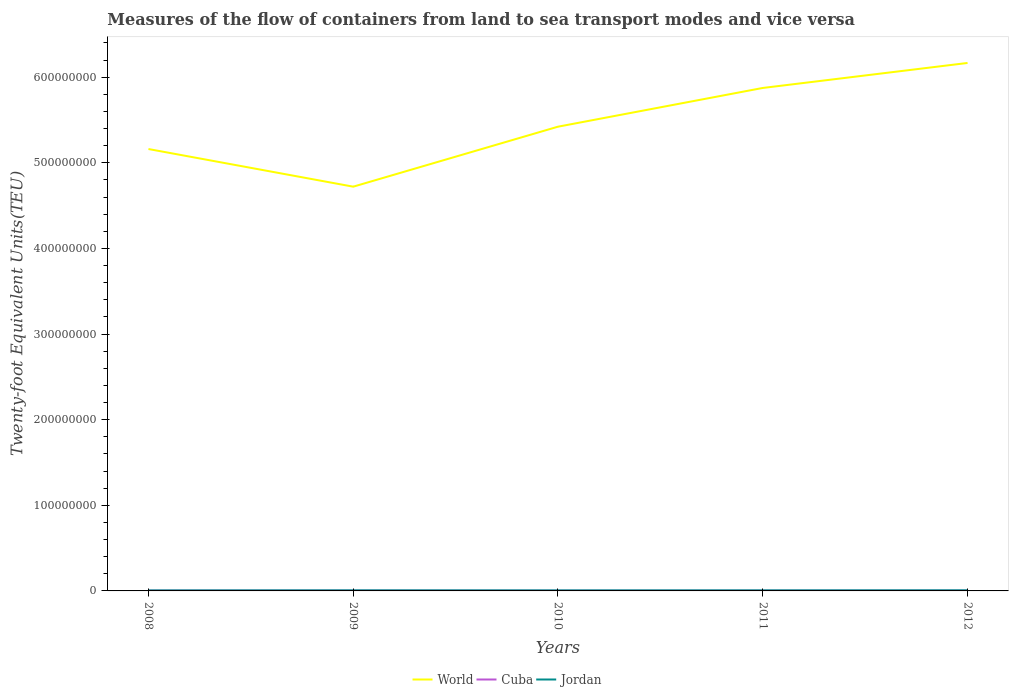Does the line corresponding to World intersect with the line corresponding to Cuba?
Offer a very short reply. No. Across all years, what is the maximum container port traffic in World?
Your answer should be very brief. 4.72e+08. What is the total container port traffic in Cuba in the graph?
Make the answer very short. 9.07e+04. What is the difference between the highest and the second highest container port traffic in World?
Offer a terse response. 1.44e+08. What is the difference between two consecutive major ticks on the Y-axis?
Make the answer very short. 1.00e+08. Are the values on the major ticks of Y-axis written in scientific E-notation?
Give a very brief answer. No. Does the graph contain grids?
Your response must be concise. No. Where does the legend appear in the graph?
Your response must be concise. Bottom center. What is the title of the graph?
Offer a very short reply. Measures of the flow of containers from land to sea transport modes and vice versa. What is the label or title of the X-axis?
Your answer should be very brief. Years. What is the label or title of the Y-axis?
Provide a succinct answer. Twenty-foot Equivalent Units(TEU). What is the Twenty-foot Equivalent Units(TEU) of World in 2008?
Your answer should be very brief. 5.16e+08. What is the Twenty-foot Equivalent Units(TEU) of Cuba in 2008?
Provide a succinct answer. 3.19e+05. What is the Twenty-foot Equivalent Units(TEU) in Jordan in 2008?
Your answer should be compact. 5.83e+05. What is the Twenty-foot Equivalent Units(TEU) in World in 2009?
Provide a short and direct response. 4.72e+08. What is the Twenty-foot Equivalent Units(TEU) in Cuba in 2009?
Ensure brevity in your answer.  2.90e+05. What is the Twenty-foot Equivalent Units(TEU) in Jordan in 2009?
Make the answer very short. 6.75e+05. What is the Twenty-foot Equivalent Units(TEU) of World in 2010?
Give a very brief answer. 5.42e+08. What is the Twenty-foot Equivalent Units(TEU) in Cuba in 2010?
Your answer should be very brief. 2.28e+05. What is the Twenty-foot Equivalent Units(TEU) in Jordan in 2010?
Make the answer very short. 6.19e+05. What is the Twenty-foot Equivalent Units(TEU) of World in 2011?
Keep it short and to the point. 5.87e+08. What is the Twenty-foot Equivalent Units(TEU) of Cuba in 2011?
Your response must be concise. 2.47e+05. What is the Twenty-foot Equivalent Units(TEU) of Jordan in 2011?
Keep it short and to the point. 6.54e+05. What is the Twenty-foot Equivalent Units(TEU) of World in 2012?
Make the answer very short. 6.17e+08. What is the Twenty-foot Equivalent Units(TEU) in Cuba in 2012?
Make the answer very short. 2.65e+05. What is the Twenty-foot Equivalent Units(TEU) of Jordan in 2012?
Your response must be concise. 7.03e+05. Across all years, what is the maximum Twenty-foot Equivalent Units(TEU) of World?
Give a very brief answer. 6.17e+08. Across all years, what is the maximum Twenty-foot Equivalent Units(TEU) in Cuba?
Provide a succinct answer. 3.19e+05. Across all years, what is the maximum Twenty-foot Equivalent Units(TEU) in Jordan?
Offer a terse response. 7.03e+05. Across all years, what is the minimum Twenty-foot Equivalent Units(TEU) of World?
Provide a short and direct response. 4.72e+08. Across all years, what is the minimum Twenty-foot Equivalent Units(TEU) of Cuba?
Provide a succinct answer. 2.28e+05. Across all years, what is the minimum Twenty-foot Equivalent Units(TEU) in Jordan?
Offer a terse response. 5.83e+05. What is the total Twenty-foot Equivalent Units(TEU) of World in the graph?
Offer a very short reply. 2.73e+09. What is the total Twenty-foot Equivalent Units(TEU) in Cuba in the graph?
Provide a short and direct response. 1.35e+06. What is the total Twenty-foot Equivalent Units(TEU) in Jordan in the graph?
Offer a terse response. 3.23e+06. What is the difference between the Twenty-foot Equivalent Units(TEU) in World in 2008 and that in 2009?
Your answer should be very brief. 4.40e+07. What is the difference between the Twenty-foot Equivalent Units(TEU) in Cuba in 2008 and that in 2009?
Provide a succinct answer. 2.89e+04. What is the difference between the Twenty-foot Equivalent Units(TEU) of Jordan in 2008 and that in 2009?
Make the answer very short. -9.20e+04. What is the difference between the Twenty-foot Equivalent Units(TEU) of World in 2008 and that in 2010?
Your answer should be compact. -2.61e+07. What is the difference between the Twenty-foot Equivalent Units(TEU) of Cuba in 2008 and that in 2010?
Your answer should be very brief. 9.07e+04. What is the difference between the Twenty-foot Equivalent Units(TEU) in Jordan in 2008 and that in 2010?
Provide a succinct answer. -3.65e+04. What is the difference between the Twenty-foot Equivalent Units(TEU) of World in 2008 and that in 2011?
Give a very brief answer. -7.13e+07. What is the difference between the Twenty-foot Equivalent Units(TEU) of Cuba in 2008 and that in 2011?
Give a very brief answer. 7.22e+04. What is the difference between the Twenty-foot Equivalent Units(TEU) of Jordan in 2008 and that in 2011?
Give a very brief answer. -7.18e+04. What is the difference between the Twenty-foot Equivalent Units(TEU) of World in 2008 and that in 2012?
Offer a very short reply. -1.01e+08. What is the difference between the Twenty-foot Equivalent Units(TEU) in Cuba in 2008 and that in 2012?
Ensure brevity in your answer.  5.37e+04. What is the difference between the Twenty-foot Equivalent Units(TEU) of Jordan in 2008 and that in 2012?
Offer a terse response. -1.21e+05. What is the difference between the Twenty-foot Equivalent Units(TEU) of World in 2009 and that in 2010?
Your response must be concise. -7.01e+07. What is the difference between the Twenty-foot Equivalent Units(TEU) of Cuba in 2009 and that in 2010?
Keep it short and to the point. 6.18e+04. What is the difference between the Twenty-foot Equivalent Units(TEU) of Jordan in 2009 and that in 2010?
Provide a short and direct response. 5.55e+04. What is the difference between the Twenty-foot Equivalent Units(TEU) of World in 2009 and that in 2011?
Your answer should be compact. -1.15e+08. What is the difference between the Twenty-foot Equivalent Units(TEU) of Cuba in 2009 and that in 2011?
Give a very brief answer. 4.33e+04. What is the difference between the Twenty-foot Equivalent Units(TEU) in Jordan in 2009 and that in 2011?
Give a very brief answer. 2.02e+04. What is the difference between the Twenty-foot Equivalent Units(TEU) in World in 2009 and that in 2012?
Your answer should be compact. -1.44e+08. What is the difference between the Twenty-foot Equivalent Units(TEU) of Cuba in 2009 and that in 2012?
Ensure brevity in your answer.  2.48e+04. What is the difference between the Twenty-foot Equivalent Units(TEU) of Jordan in 2009 and that in 2012?
Provide a succinct answer. -2.88e+04. What is the difference between the Twenty-foot Equivalent Units(TEU) of World in 2010 and that in 2011?
Ensure brevity in your answer.  -4.52e+07. What is the difference between the Twenty-foot Equivalent Units(TEU) in Cuba in 2010 and that in 2011?
Give a very brief answer. -1.84e+04. What is the difference between the Twenty-foot Equivalent Units(TEU) in Jordan in 2010 and that in 2011?
Offer a terse response. -3.53e+04. What is the difference between the Twenty-foot Equivalent Units(TEU) of World in 2010 and that in 2012?
Your answer should be compact. -7.44e+07. What is the difference between the Twenty-foot Equivalent Units(TEU) of Cuba in 2010 and that in 2012?
Offer a terse response. -3.69e+04. What is the difference between the Twenty-foot Equivalent Units(TEU) in Jordan in 2010 and that in 2012?
Provide a short and direct response. -8.44e+04. What is the difference between the Twenty-foot Equivalent Units(TEU) of World in 2011 and that in 2012?
Your answer should be compact. -2.92e+07. What is the difference between the Twenty-foot Equivalent Units(TEU) in Cuba in 2011 and that in 2012?
Your answer should be compact. -1.85e+04. What is the difference between the Twenty-foot Equivalent Units(TEU) of Jordan in 2011 and that in 2012?
Offer a terse response. -4.91e+04. What is the difference between the Twenty-foot Equivalent Units(TEU) in World in 2008 and the Twenty-foot Equivalent Units(TEU) in Cuba in 2009?
Offer a terse response. 5.16e+08. What is the difference between the Twenty-foot Equivalent Units(TEU) in World in 2008 and the Twenty-foot Equivalent Units(TEU) in Jordan in 2009?
Keep it short and to the point. 5.15e+08. What is the difference between the Twenty-foot Equivalent Units(TEU) of Cuba in 2008 and the Twenty-foot Equivalent Units(TEU) of Jordan in 2009?
Provide a succinct answer. -3.56e+05. What is the difference between the Twenty-foot Equivalent Units(TEU) of World in 2008 and the Twenty-foot Equivalent Units(TEU) of Cuba in 2010?
Offer a very short reply. 5.16e+08. What is the difference between the Twenty-foot Equivalent Units(TEU) of World in 2008 and the Twenty-foot Equivalent Units(TEU) of Jordan in 2010?
Your answer should be very brief. 5.16e+08. What is the difference between the Twenty-foot Equivalent Units(TEU) in World in 2008 and the Twenty-foot Equivalent Units(TEU) in Cuba in 2011?
Keep it short and to the point. 5.16e+08. What is the difference between the Twenty-foot Equivalent Units(TEU) in World in 2008 and the Twenty-foot Equivalent Units(TEU) in Jordan in 2011?
Your answer should be very brief. 5.15e+08. What is the difference between the Twenty-foot Equivalent Units(TEU) in Cuba in 2008 and the Twenty-foot Equivalent Units(TEU) in Jordan in 2011?
Give a very brief answer. -3.35e+05. What is the difference between the Twenty-foot Equivalent Units(TEU) of World in 2008 and the Twenty-foot Equivalent Units(TEU) of Cuba in 2012?
Keep it short and to the point. 5.16e+08. What is the difference between the Twenty-foot Equivalent Units(TEU) of World in 2008 and the Twenty-foot Equivalent Units(TEU) of Jordan in 2012?
Provide a short and direct response. 5.15e+08. What is the difference between the Twenty-foot Equivalent Units(TEU) in Cuba in 2008 and the Twenty-foot Equivalent Units(TEU) in Jordan in 2012?
Offer a terse response. -3.84e+05. What is the difference between the Twenty-foot Equivalent Units(TEU) of World in 2009 and the Twenty-foot Equivalent Units(TEU) of Cuba in 2010?
Ensure brevity in your answer.  4.72e+08. What is the difference between the Twenty-foot Equivalent Units(TEU) in World in 2009 and the Twenty-foot Equivalent Units(TEU) in Jordan in 2010?
Your answer should be compact. 4.72e+08. What is the difference between the Twenty-foot Equivalent Units(TEU) in Cuba in 2009 and the Twenty-foot Equivalent Units(TEU) in Jordan in 2010?
Give a very brief answer. -3.29e+05. What is the difference between the Twenty-foot Equivalent Units(TEU) in World in 2009 and the Twenty-foot Equivalent Units(TEU) in Cuba in 2011?
Ensure brevity in your answer.  4.72e+08. What is the difference between the Twenty-foot Equivalent Units(TEU) in World in 2009 and the Twenty-foot Equivalent Units(TEU) in Jordan in 2011?
Make the answer very short. 4.72e+08. What is the difference between the Twenty-foot Equivalent Units(TEU) of Cuba in 2009 and the Twenty-foot Equivalent Units(TEU) of Jordan in 2011?
Give a very brief answer. -3.64e+05. What is the difference between the Twenty-foot Equivalent Units(TEU) in World in 2009 and the Twenty-foot Equivalent Units(TEU) in Cuba in 2012?
Offer a very short reply. 4.72e+08. What is the difference between the Twenty-foot Equivalent Units(TEU) in World in 2009 and the Twenty-foot Equivalent Units(TEU) in Jordan in 2012?
Your answer should be very brief. 4.71e+08. What is the difference between the Twenty-foot Equivalent Units(TEU) of Cuba in 2009 and the Twenty-foot Equivalent Units(TEU) of Jordan in 2012?
Your answer should be compact. -4.13e+05. What is the difference between the Twenty-foot Equivalent Units(TEU) in World in 2010 and the Twenty-foot Equivalent Units(TEU) in Cuba in 2011?
Offer a very short reply. 5.42e+08. What is the difference between the Twenty-foot Equivalent Units(TEU) of World in 2010 and the Twenty-foot Equivalent Units(TEU) of Jordan in 2011?
Provide a succinct answer. 5.42e+08. What is the difference between the Twenty-foot Equivalent Units(TEU) in Cuba in 2010 and the Twenty-foot Equivalent Units(TEU) in Jordan in 2011?
Make the answer very short. -4.26e+05. What is the difference between the Twenty-foot Equivalent Units(TEU) of World in 2010 and the Twenty-foot Equivalent Units(TEU) of Cuba in 2012?
Provide a succinct answer. 5.42e+08. What is the difference between the Twenty-foot Equivalent Units(TEU) in World in 2010 and the Twenty-foot Equivalent Units(TEU) in Jordan in 2012?
Offer a very short reply. 5.42e+08. What is the difference between the Twenty-foot Equivalent Units(TEU) of Cuba in 2010 and the Twenty-foot Equivalent Units(TEU) of Jordan in 2012?
Your answer should be compact. -4.75e+05. What is the difference between the Twenty-foot Equivalent Units(TEU) of World in 2011 and the Twenty-foot Equivalent Units(TEU) of Cuba in 2012?
Ensure brevity in your answer.  5.87e+08. What is the difference between the Twenty-foot Equivalent Units(TEU) of World in 2011 and the Twenty-foot Equivalent Units(TEU) of Jordan in 2012?
Provide a short and direct response. 5.87e+08. What is the difference between the Twenty-foot Equivalent Units(TEU) of Cuba in 2011 and the Twenty-foot Equivalent Units(TEU) of Jordan in 2012?
Your response must be concise. -4.57e+05. What is the average Twenty-foot Equivalent Units(TEU) in World per year?
Offer a terse response. 5.47e+08. What is the average Twenty-foot Equivalent Units(TEU) in Cuba per year?
Give a very brief answer. 2.70e+05. What is the average Twenty-foot Equivalent Units(TEU) in Jordan per year?
Your answer should be compact. 6.47e+05. In the year 2008, what is the difference between the Twenty-foot Equivalent Units(TEU) in World and Twenty-foot Equivalent Units(TEU) in Cuba?
Offer a terse response. 5.16e+08. In the year 2008, what is the difference between the Twenty-foot Equivalent Units(TEU) in World and Twenty-foot Equivalent Units(TEU) in Jordan?
Provide a succinct answer. 5.16e+08. In the year 2008, what is the difference between the Twenty-foot Equivalent Units(TEU) in Cuba and Twenty-foot Equivalent Units(TEU) in Jordan?
Provide a succinct answer. -2.64e+05. In the year 2009, what is the difference between the Twenty-foot Equivalent Units(TEU) of World and Twenty-foot Equivalent Units(TEU) of Cuba?
Offer a very short reply. 4.72e+08. In the year 2009, what is the difference between the Twenty-foot Equivalent Units(TEU) of World and Twenty-foot Equivalent Units(TEU) of Jordan?
Your answer should be compact. 4.72e+08. In the year 2009, what is the difference between the Twenty-foot Equivalent Units(TEU) of Cuba and Twenty-foot Equivalent Units(TEU) of Jordan?
Give a very brief answer. -3.84e+05. In the year 2010, what is the difference between the Twenty-foot Equivalent Units(TEU) of World and Twenty-foot Equivalent Units(TEU) of Cuba?
Make the answer very short. 5.42e+08. In the year 2010, what is the difference between the Twenty-foot Equivalent Units(TEU) in World and Twenty-foot Equivalent Units(TEU) in Jordan?
Your answer should be very brief. 5.42e+08. In the year 2010, what is the difference between the Twenty-foot Equivalent Units(TEU) in Cuba and Twenty-foot Equivalent Units(TEU) in Jordan?
Give a very brief answer. -3.91e+05. In the year 2011, what is the difference between the Twenty-foot Equivalent Units(TEU) of World and Twenty-foot Equivalent Units(TEU) of Cuba?
Provide a short and direct response. 5.87e+08. In the year 2011, what is the difference between the Twenty-foot Equivalent Units(TEU) of World and Twenty-foot Equivalent Units(TEU) of Jordan?
Your response must be concise. 5.87e+08. In the year 2011, what is the difference between the Twenty-foot Equivalent Units(TEU) in Cuba and Twenty-foot Equivalent Units(TEU) in Jordan?
Your answer should be compact. -4.08e+05. In the year 2012, what is the difference between the Twenty-foot Equivalent Units(TEU) of World and Twenty-foot Equivalent Units(TEU) of Cuba?
Provide a succinct answer. 6.16e+08. In the year 2012, what is the difference between the Twenty-foot Equivalent Units(TEU) of World and Twenty-foot Equivalent Units(TEU) of Jordan?
Give a very brief answer. 6.16e+08. In the year 2012, what is the difference between the Twenty-foot Equivalent Units(TEU) of Cuba and Twenty-foot Equivalent Units(TEU) of Jordan?
Ensure brevity in your answer.  -4.38e+05. What is the ratio of the Twenty-foot Equivalent Units(TEU) of World in 2008 to that in 2009?
Offer a very short reply. 1.09. What is the ratio of the Twenty-foot Equivalent Units(TEU) of Cuba in 2008 to that in 2009?
Give a very brief answer. 1.1. What is the ratio of the Twenty-foot Equivalent Units(TEU) in Jordan in 2008 to that in 2009?
Your answer should be very brief. 0.86. What is the ratio of the Twenty-foot Equivalent Units(TEU) of World in 2008 to that in 2010?
Ensure brevity in your answer.  0.95. What is the ratio of the Twenty-foot Equivalent Units(TEU) of Cuba in 2008 to that in 2010?
Offer a terse response. 1.4. What is the ratio of the Twenty-foot Equivalent Units(TEU) of Jordan in 2008 to that in 2010?
Keep it short and to the point. 0.94. What is the ratio of the Twenty-foot Equivalent Units(TEU) of World in 2008 to that in 2011?
Ensure brevity in your answer.  0.88. What is the ratio of the Twenty-foot Equivalent Units(TEU) in Cuba in 2008 to that in 2011?
Ensure brevity in your answer.  1.29. What is the ratio of the Twenty-foot Equivalent Units(TEU) in Jordan in 2008 to that in 2011?
Offer a terse response. 0.89. What is the ratio of the Twenty-foot Equivalent Units(TEU) of World in 2008 to that in 2012?
Ensure brevity in your answer.  0.84. What is the ratio of the Twenty-foot Equivalent Units(TEU) in Cuba in 2008 to that in 2012?
Keep it short and to the point. 1.2. What is the ratio of the Twenty-foot Equivalent Units(TEU) of Jordan in 2008 to that in 2012?
Ensure brevity in your answer.  0.83. What is the ratio of the Twenty-foot Equivalent Units(TEU) in World in 2009 to that in 2010?
Your response must be concise. 0.87. What is the ratio of the Twenty-foot Equivalent Units(TEU) in Cuba in 2009 to that in 2010?
Provide a succinct answer. 1.27. What is the ratio of the Twenty-foot Equivalent Units(TEU) in Jordan in 2009 to that in 2010?
Keep it short and to the point. 1.09. What is the ratio of the Twenty-foot Equivalent Units(TEU) of World in 2009 to that in 2011?
Make the answer very short. 0.8. What is the ratio of the Twenty-foot Equivalent Units(TEU) in Cuba in 2009 to that in 2011?
Your response must be concise. 1.18. What is the ratio of the Twenty-foot Equivalent Units(TEU) of Jordan in 2009 to that in 2011?
Your answer should be compact. 1.03. What is the ratio of the Twenty-foot Equivalent Units(TEU) in World in 2009 to that in 2012?
Give a very brief answer. 0.77. What is the ratio of the Twenty-foot Equivalent Units(TEU) of Cuba in 2009 to that in 2012?
Keep it short and to the point. 1.09. What is the ratio of the Twenty-foot Equivalent Units(TEU) in Jordan in 2009 to that in 2012?
Ensure brevity in your answer.  0.96. What is the ratio of the Twenty-foot Equivalent Units(TEU) in World in 2010 to that in 2011?
Your answer should be very brief. 0.92. What is the ratio of the Twenty-foot Equivalent Units(TEU) of Cuba in 2010 to that in 2011?
Provide a succinct answer. 0.93. What is the ratio of the Twenty-foot Equivalent Units(TEU) of Jordan in 2010 to that in 2011?
Offer a very short reply. 0.95. What is the ratio of the Twenty-foot Equivalent Units(TEU) in World in 2010 to that in 2012?
Make the answer very short. 0.88. What is the ratio of the Twenty-foot Equivalent Units(TEU) in Cuba in 2010 to that in 2012?
Your answer should be compact. 0.86. What is the ratio of the Twenty-foot Equivalent Units(TEU) of Jordan in 2010 to that in 2012?
Make the answer very short. 0.88. What is the ratio of the Twenty-foot Equivalent Units(TEU) of World in 2011 to that in 2012?
Give a very brief answer. 0.95. What is the ratio of the Twenty-foot Equivalent Units(TEU) of Cuba in 2011 to that in 2012?
Keep it short and to the point. 0.93. What is the ratio of the Twenty-foot Equivalent Units(TEU) of Jordan in 2011 to that in 2012?
Your answer should be compact. 0.93. What is the difference between the highest and the second highest Twenty-foot Equivalent Units(TEU) of World?
Provide a succinct answer. 2.92e+07. What is the difference between the highest and the second highest Twenty-foot Equivalent Units(TEU) in Cuba?
Keep it short and to the point. 2.89e+04. What is the difference between the highest and the second highest Twenty-foot Equivalent Units(TEU) of Jordan?
Ensure brevity in your answer.  2.88e+04. What is the difference between the highest and the lowest Twenty-foot Equivalent Units(TEU) in World?
Provide a succinct answer. 1.44e+08. What is the difference between the highest and the lowest Twenty-foot Equivalent Units(TEU) of Cuba?
Provide a short and direct response. 9.07e+04. What is the difference between the highest and the lowest Twenty-foot Equivalent Units(TEU) in Jordan?
Keep it short and to the point. 1.21e+05. 